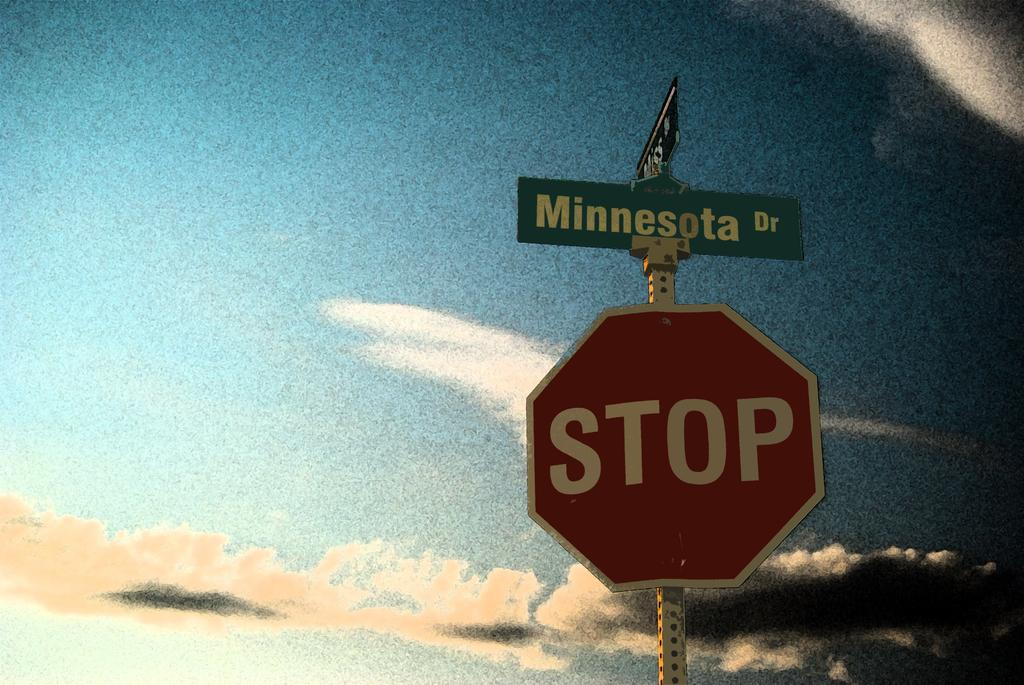<image>
Offer a succinct explanation of the picture presented. A red stop sign against a blue cloud filled sky. 